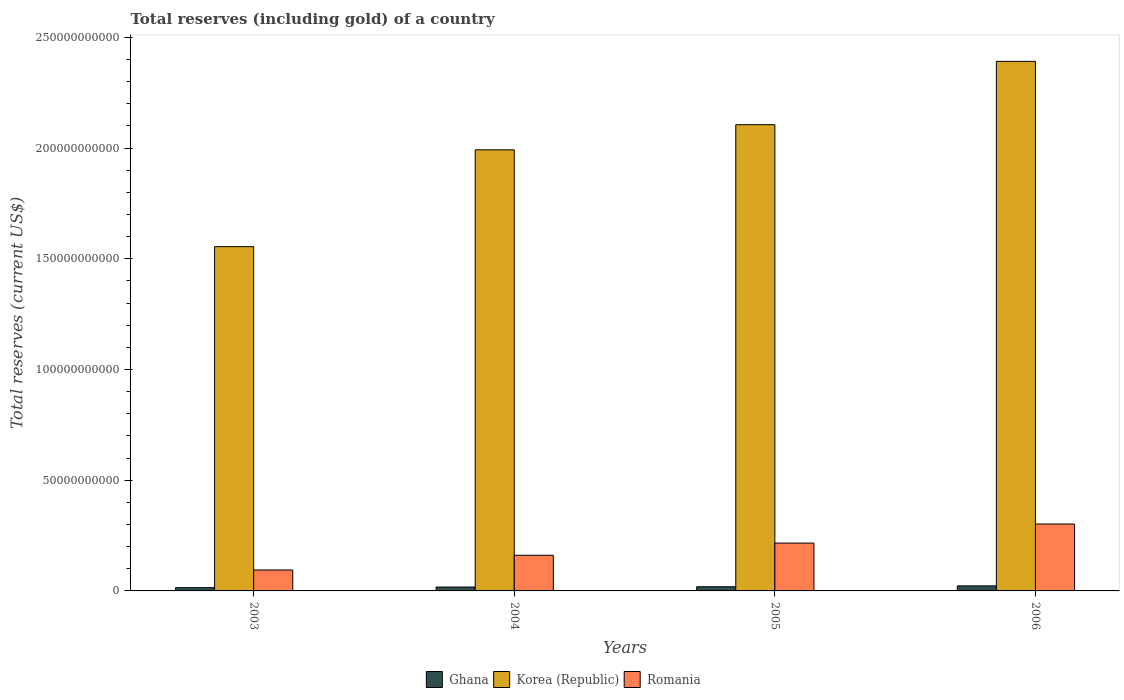Are the number of bars per tick equal to the number of legend labels?
Make the answer very short. Yes. How many bars are there on the 2nd tick from the left?
Provide a succinct answer. 3. What is the label of the 4th group of bars from the left?
Ensure brevity in your answer.  2006. In how many cases, is the number of bars for a given year not equal to the number of legend labels?
Provide a short and direct response. 0. What is the total reserves (including gold) in Romania in 2006?
Keep it short and to the point. 3.02e+1. Across all years, what is the maximum total reserves (including gold) in Korea (Republic)?
Ensure brevity in your answer.  2.39e+11. Across all years, what is the minimum total reserves (including gold) in Romania?
Give a very brief answer. 9.45e+09. In which year was the total reserves (including gold) in Ghana minimum?
Your response must be concise. 2003. What is the total total reserves (including gold) in Romania in the graph?
Keep it short and to the point. 7.74e+1. What is the difference between the total reserves (including gold) in Korea (Republic) in 2004 and that in 2005?
Your answer should be compact. -1.14e+1. What is the difference between the total reserves (including gold) in Ghana in 2003 and the total reserves (including gold) in Korea (Republic) in 2004?
Make the answer very short. -1.98e+11. What is the average total reserves (including gold) in Korea (Republic) per year?
Offer a very short reply. 2.01e+11. In the year 2003, what is the difference between the total reserves (including gold) in Romania and total reserves (including gold) in Ghana?
Give a very brief answer. 7.98e+09. In how many years, is the total reserves (including gold) in Korea (Republic) greater than 150000000000 US$?
Make the answer very short. 4. What is the ratio of the total reserves (including gold) in Ghana in 2004 to that in 2006?
Offer a terse response. 0.77. Is the total reserves (including gold) in Korea (Republic) in 2004 less than that in 2006?
Keep it short and to the point. Yes. What is the difference between the highest and the second highest total reserves (including gold) in Korea (Republic)?
Provide a short and direct response. 2.86e+1. What is the difference between the highest and the lowest total reserves (including gold) in Romania?
Keep it short and to the point. 2.08e+1. Is the sum of the total reserves (including gold) in Romania in 2003 and 2006 greater than the maximum total reserves (including gold) in Korea (Republic) across all years?
Provide a short and direct response. No. What does the 3rd bar from the left in 2006 represents?
Ensure brevity in your answer.  Romania. What does the 1st bar from the right in 2003 represents?
Your answer should be very brief. Romania. Are all the bars in the graph horizontal?
Keep it short and to the point. No. How many years are there in the graph?
Your answer should be compact. 4. What is the difference between two consecutive major ticks on the Y-axis?
Provide a succinct answer. 5.00e+1. Are the values on the major ticks of Y-axis written in scientific E-notation?
Your response must be concise. No. Does the graph contain any zero values?
Your answer should be very brief. No. Where does the legend appear in the graph?
Keep it short and to the point. Bottom center. How many legend labels are there?
Provide a short and direct response. 3. How are the legend labels stacked?
Your response must be concise. Horizontal. What is the title of the graph?
Keep it short and to the point. Total reserves (including gold) of a country. Does "India" appear as one of the legend labels in the graph?
Offer a terse response. No. What is the label or title of the X-axis?
Provide a short and direct response. Years. What is the label or title of the Y-axis?
Your response must be concise. Total reserves (current US$). What is the Total reserves (current US$) in Ghana in 2003?
Offer a very short reply. 1.47e+09. What is the Total reserves (current US$) in Korea (Republic) in 2003?
Provide a succinct answer. 1.55e+11. What is the Total reserves (current US$) in Romania in 2003?
Make the answer very short. 9.45e+09. What is the Total reserves (current US$) of Ghana in 2004?
Provide a short and direct response. 1.75e+09. What is the Total reserves (current US$) of Korea (Republic) in 2004?
Offer a terse response. 1.99e+11. What is the Total reserves (current US$) in Romania in 2004?
Offer a very short reply. 1.61e+1. What is the Total reserves (current US$) in Ghana in 2005?
Provide a succinct answer. 1.90e+09. What is the Total reserves (current US$) of Korea (Republic) in 2005?
Your answer should be very brief. 2.11e+11. What is the Total reserves (current US$) of Romania in 2005?
Your response must be concise. 2.16e+1. What is the Total reserves (current US$) of Ghana in 2006?
Give a very brief answer. 2.27e+09. What is the Total reserves (current US$) in Korea (Republic) in 2006?
Provide a succinct answer. 2.39e+11. What is the Total reserves (current US$) of Romania in 2006?
Keep it short and to the point. 3.02e+1. Across all years, what is the maximum Total reserves (current US$) in Ghana?
Give a very brief answer. 2.27e+09. Across all years, what is the maximum Total reserves (current US$) of Korea (Republic)?
Provide a short and direct response. 2.39e+11. Across all years, what is the maximum Total reserves (current US$) in Romania?
Provide a succinct answer. 3.02e+1. Across all years, what is the minimum Total reserves (current US$) in Ghana?
Offer a very short reply. 1.47e+09. Across all years, what is the minimum Total reserves (current US$) in Korea (Republic)?
Make the answer very short. 1.55e+11. Across all years, what is the minimum Total reserves (current US$) in Romania?
Make the answer very short. 9.45e+09. What is the total Total reserves (current US$) of Ghana in the graph?
Keep it short and to the point. 7.39e+09. What is the total Total reserves (current US$) in Korea (Republic) in the graph?
Offer a very short reply. 8.04e+11. What is the total Total reserves (current US$) of Romania in the graph?
Your answer should be very brief. 7.74e+1. What is the difference between the Total reserves (current US$) in Ghana in 2003 and that in 2004?
Your response must be concise. -2.80e+08. What is the difference between the Total reserves (current US$) in Korea (Republic) in 2003 and that in 2004?
Offer a very short reply. -4.37e+1. What is the difference between the Total reserves (current US$) of Romania in 2003 and that in 2004?
Ensure brevity in your answer.  -6.65e+09. What is the difference between the Total reserves (current US$) of Ghana in 2003 and that in 2005?
Offer a very short reply. -4.27e+08. What is the difference between the Total reserves (current US$) in Korea (Republic) in 2003 and that in 2005?
Give a very brief answer. -5.51e+1. What is the difference between the Total reserves (current US$) of Romania in 2003 and that in 2005?
Provide a succinct answer. -1.22e+1. What is the difference between the Total reserves (current US$) of Ghana in 2003 and that in 2006?
Your response must be concise. -7.99e+08. What is the difference between the Total reserves (current US$) of Korea (Republic) in 2003 and that in 2006?
Provide a succinct answer. -8.37e+1. What is the difference between the Total reserves (current US$) in Romania in 2003 and that in 2006?
Make the answer very short. -2.08e+1. What is the difference between the Total reserves (current US$) of Ghana in 2004 and that in 2005?
Provide a succinct answer. -1.47e+08. What is the difference between the Total reserves (current US$) of Korea (Republic) in 2004 and that in 2005?
Make the answer very short. -1.14e+1. What is the difference between the Total reserves (current US$) of Romania in 2004 and that in 2005?
Offer a terse response. -5.51e+09. What is the difference between the Total reserves (current US$) of Ghana in 2004 and that in 2006?
Ensure brevity in your answer.  -5.19e+08. What is the difference between the Total reserves (current US$) of Korea (Republic) in 2004 and that in 2006?
Your response must be concise. -4.00e+1. What is the difference between the Total reserves (current US$) of Romania in 2004 and that in 2006?
Offer a terse response. -1.41e+1. What is the difference between the Total reserves (current US$) of Ghana in 2005 and that in 2006?
Offer a very short reply. -3.72e+08. What is the difference between the Total reserves (current US$) in Korea (Republic) in 2005 and that in 2006?
Offer a terse response. -2.86e+1. What is the difference between the Total reserves (current US$) of Romania in 2005 and that in 2006?
Ensure brevity in your answer.  -8.60e+09. What is the difference between the Total reserves (current US$) in Ghana in 2003 and the Total reserves (current US$) in Korea (Republic) in 2004?
Your answer should be very brief. -1.98e+11. What is the difference between the Total reserves (current US$) in Ghana in 2003 and the Total reserves (current US$) in Romania in 2004?
Your response must be concise. -1.46e+1. What is the difference between the Total reserves (current US$) of Korea (Republic) in 2003 and the Total reserves (current US$) of Romania in 2004?
Offer a terse response. 1.39e+11. What is the difference between the Total reserves (current US$) of Ghana in 2003 and the Total reserves (current US$) of Korea (Republic) in 2005?
Keep it short and to the point. -2.09e+11. What is the difference between the Total reserves (current US$) of Ghana in 2003 and the Total reserves (current US$) of Romania in 2005?
Provide a succinct answer. -2.01e+1. What is the difference between the Total reserves (current US$) in Korea (Republic) in 2003 and the Total reserves (current US$) in Romania in 2005?
Provide a succinct answer. 1.34e+11. What is the difference between the Total reserves (current US$) in Ghana in 2003 and the Total reserves (current US$) in Korea (Republic) in 2006?
Your answer should be very brief. -2.38e+11. What is the difference between the Total reserves (current US$) in Ghana in 2003 and the Total reserves (current US$) in Romania in 2006?
Offer a terse response. -2.87e+1. What is the difference between the Total reserves (current US$) of Korea (Republic) in 2003 and the Total reserves (current US$) of Romania in 2006?
Offer a very short reply. 1.25e+11. What is the difference between the Total reserves (current US$) in Ghana in 2004 and the Total reserves (current US$) in Korea (Republic) in 2005?
Your response must be concise. -2.09e+11. What is the difference between the Total reserves (current US$) in Ghana in 2004 and the Total reserves (current US$) in Romania in 2005?
Your answer should be very brief. -1.99e+1. What is the difference between the Total reserves (current US$) of Korea (Republic) in 2004 and the Total reserves (current US$) of Romania in 2005?
Offer a very short reply. 1.78e+11. What is the difference between the Total reserves (current US$) in Ghana in 2004 and the Total reserves (current US$) in Korea (Republic) in 2006?
Give a very brief answer. -2.37e+11. What is the difference between the Total reserves (current US$) of Ghana in 2004 and the Total reserves (current US$) of Romania in 2006?
Ensure brevity in your answer.  -2.85e+1. What is the difference between the Total reserves (current US$) in Korea (Republic) in 2004 and the Total reserves (current US$) in Romania in 2006?
Offer a terse response. 1.69e+11. What is the difference between the Total reserves (current US$) of Ghana in 2005 and the Total reserves (current US$) of Korea (Republic) in 2006?
Your answer should be very brief. -2.37e+11. What is the difference between the Total reserves (current US$) in Ghana in 2005 and the Total reserves (current US$) in Romania in 2006?
Provide a succinct answer. -2.83e+1. What is the difference between the Total reserves (current US$) in Korea (Republic) in 2005 and the Total reserves (current US$) in Romania in 2006?
Your response must be concise. 1.80e+11. What is the average Total reserves (current US$) in Ghana per year?
Your answer should be very brief. 1.85e+09. What is the average Total reserves (current US$) of Korea (Republic) per year?
Keep it short and to the point. 2.01e+11. What is the average Total reserves (current US$) of Romania per year?
Your answer should be very brief. 1.93e+1. In the year 2003, what is the difference between the Total reserves (current US$) in Ghana and Total reserves (current US$) in Korea (Republic)?
Your answer should be very brief. -1.54e+11. In the year 2003, what is the difference between the Total reserves (current US$) of Ghana and Total reserves (current US$) of Romania?
Make the answer very short. -7.98e+09. In the year 2003, what is the difference between the Total reserves (current US$) of Korea (Republic) and Total reserves (current US$) of Romania?
Give a very brief answer. 1.46e+11. In the year 2004, what is the difference between the Total reserves (current US$) in Ghana and Total reserves (current US$) in Korea (Republic)?
Provide a succinct answer. -1.97e+11. In the year 2004, what is the difference between the Total reserves (current US$) of Ghana and Total reserves (current US$) of Romania?
Provide a short and direct response. -1.43e+1. In the year 2004, what is the difference between the Total reserves (current US$) in Korea (Republic) and Total reserves (current US$) in Romania?
Ensure brevity in your answer.  1.83e+11. In the year 2005, what is the difference between the Total reserves (current US$) of Ghana and Total reserves (current US$) of Korea (Republic)?
Offer a very short reply. -2.09e+11. In the year 2005, what is the difference between the Total reserves (current US$) of Ghana and Total reserves (current US$) of Romania?
Your answer should be compact. -1.97e+1. In the year 2005, what is the difference between the Total reserves (current US$) in Korea (Republic) and Total reserves (current US$) in Romania?
Provide a short and direct response. 1.89e+11. In the year 2006, what is the difference between the Total reserves (current US$) in Ghana and Total reserves (current US$) in Korea (Republic)?
Offer a terse response. -2.37e+11. In the year 2006, what is the difference between the Total reserves (current US$) in Ghana and Total reserves (current US$) in Romania?
Keep it short and to the point. -2.79e+1. In the year 2006, what is the difference between the Total reserves (current US$) of Korea (Republic) and Total reserves (current US$) of Romania?
Offer a terse response. 2.09e+11. What is the ratio of the Total reserves (current US$) in Ghana in 2003 to that in 2004?
Your answer should be very brief. 0.84. What is the ratio of the Total reserves (current US$) of Korea (Republic) in 2003 to that in 2004?
Your answer should be very brief. 0.78. What is the ratio of the Total reserves (current US$) in Romania in 2003 to that in 2004?
Provide a succinct answer. 0.59. What is the ratio of the Total reserves (current US$) in Ghana in 2003 to that in 2005?
Ensure brevity in your answer.  0.77. What is the ratio of the Total reserves (current US$) in Korea (Republic) in 2003 to that in 2005?
Make the answer very short. 0.74. What is the ratio of the Total reserves (current US$) in Romania in 2003 to that in 2005?
Your answer should be very brief. 0.44. What is the ratio of the Total reserves (current US$) of Ghana in 2003 to that in 2006?
Keep it short and to the point. 0.65. What is the ratio of the Total reserves (current US$) of Korea (Republic) in 2003 to that in 2006?
Ensure brevity in your answer.  0.65. What is the ratio of the Total reserves (current US$) of Romania in 2003 to that in 2006?
Keep it short and to the point. 0.31. What is the ratio of the Total reserves (current US$) in Ghana in 2004 to that in 2005?
Offer a terse response. 0.92. What is the ratio of the Total reserves (current US$) of Korea (Republic) in 2004 to that in 2005?
Your answer should be compact. 0.95. What is the ratio of the Total reserves (current US$) of Romania in 2004 to that in 2005?
Ensure brevity in your answer.  0.75. What is the ratio of the Total reserves (current US$) of Ghana in 2004 to that in 2006?
Make the answer very short. 0.77. What is the ratio of the Total reserves (current US$) in Korea (Republic) in 2004 to that in 2006?
Your response must be concise. 0.83. What is the ratio of the Total reserves (current US$) of Romania in 2004 to that in 2006?
Provide a succinct answer. 0.53. What is the ratio of the Total reserves (current US$) in Ghana in 2005 to that in 2006?
Offer a terse response. 0.84. What is the ratio of the Total reserves (current US$) of Korea (Republic) in 2005 to that in 2006?
Ensure brevity in your answer.  0.88. What is the ratio of the Total reserves (current US$) in Romania in 2005 to that in 2006?
Offer a terse response. 0.72. What is the difference between the highest and the second highest Total reserves (current US$) of Ghana?
Make the answer very short. 3.72e+08. What is the difference between the highest and the second highest Total reserves (current US$) of Korea (Republic)?
Keep it short and to the point. 2.86e+1. What is the difference between the highest and the second highest Total reserves (current US$) in Romania?
Ensure brevity in your answer.  8.60e+09. What is the difference between the highest and the lowest Total reserves (current US$) in Ghana?
Provide a succinct answer. 7.99e+08. What is the difference between the highest and the lowest Total reserves (current US$) in Korea (Republic)?
Ensure brevity in your answer.  8.37e+1. What is the difference between the highest and the lowest Total reserves (current US$) in Romania?
Keep it short and to the point. 2.08e+1. 